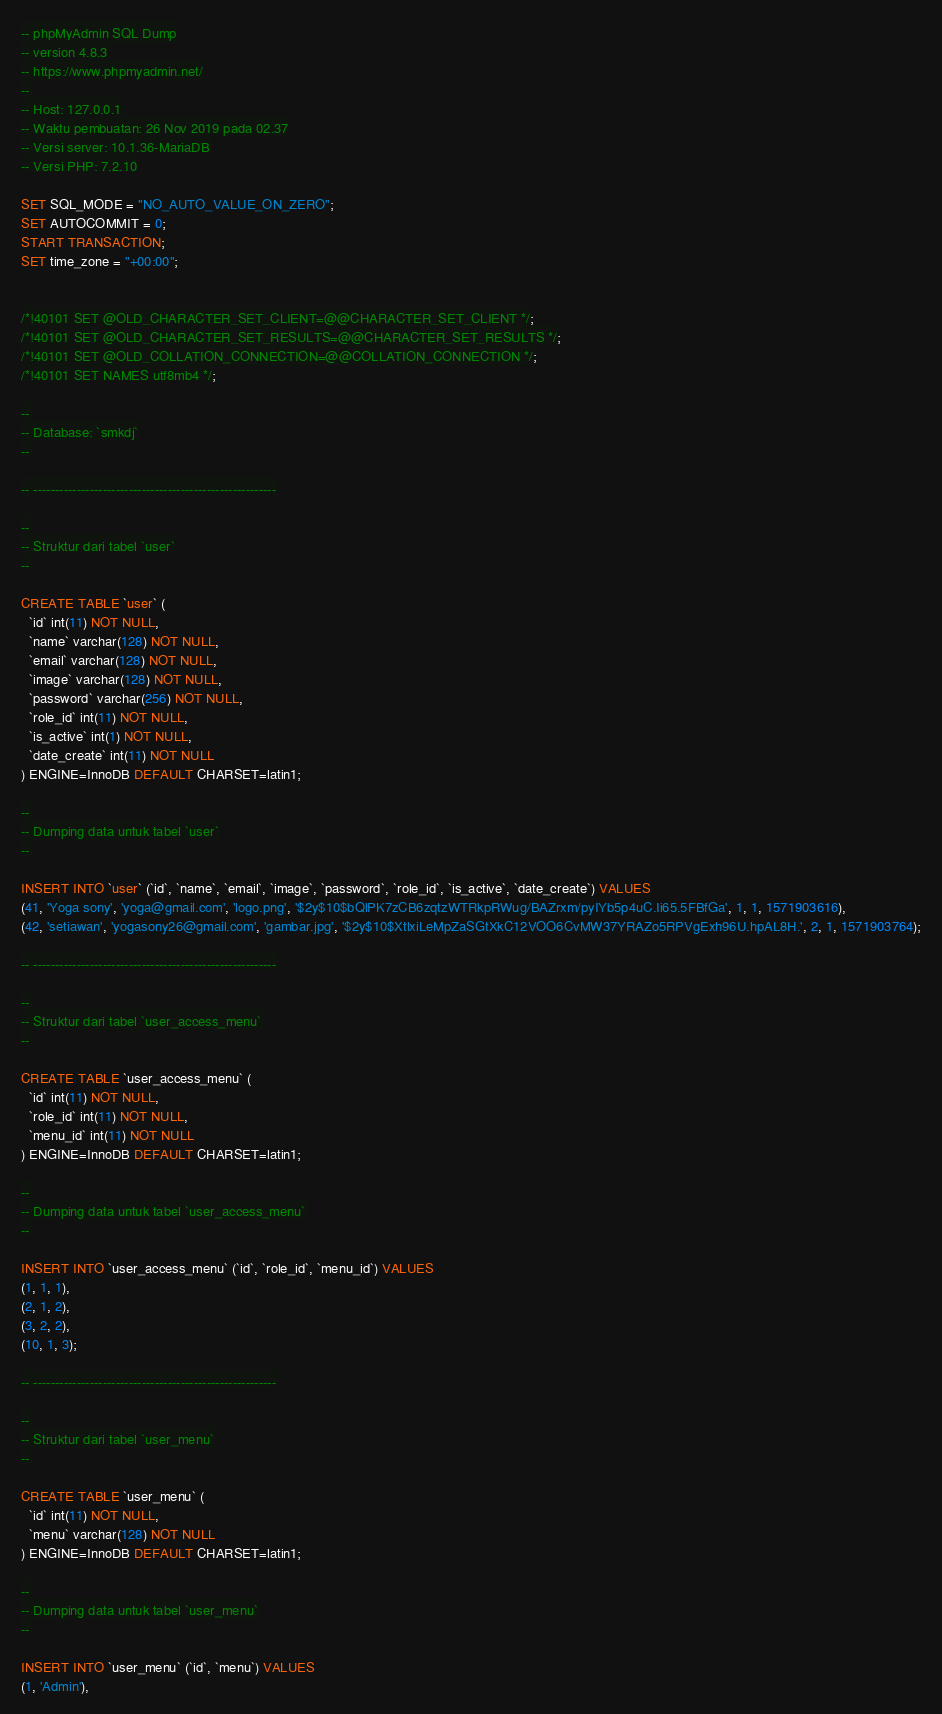<code> <loc_0><loc_0><loc_500><loc_500><_SQL_>-- phpMyAdmin SQL Dump
-- version 4.8.3
-- https://www.phpmyadmin.net/
--
-- Host: 127.0.0.1
-- Waktu pembuatan: 26 Nov 2019 pada 02.37
-- Versi server: 10.1.36-MariaDB
-- Versi PHP: 7.2.10

SET SQL_MODE = "NO_AUTO_VALUE_ON_ZERO";
SET AUTOCOMMIT = 0;
START TRANSACTION;
SET time_zone = "+00:00";


/*!40101 SET @OLD_CHARACTER_SET_CLIENT=@@CHARACTER_SET_CLIENT */;
/*!40101 SET @OLD_CHARACTER_SET_RESULTS=@@CHARACTER_SET_RESULTS */;
/*!40101 SET @OLD_COLLATION_CONNECTION=@@COLLATION_CONNECTION */;
/*!40101 SET NAMES utf8mb4 */;

--
-- Database: `smkdj`
--

-- --------------------------------------------------------

--
-- Struktur dari tabel `user`
--

CREATE TABLE `user` (
  `id` int(11) NOT NULL,
  `name` varchar(128) NOT NULL,
  `email` varchar(128) NOT NULL,
  `image` varchar(128) NOT NULL,
  `password` varchar(256) NOT NULL,
  `role_id` int(11) NOT NULL,
  `is_active` int(1) NOT NULL,
  `date_create` int(11) NOT NULL
) ENGINE=InnoDB DEFAULT CHARSET=latin1;

--
-- Dumping data untuk tabel `user`
--

INSERT INTO `user` (`id`, `name`, `email`, `image`, `password`, `role_id`, `is_active`, `date_create`) VALUES
(41, 'Yoga sony', 'yoga@gmail.com', 'logo.png', '$2y$10$bQlPK7zCB6zqtzWTRkpRWug/BAZrxm/pyIYb5p4uC.Ii65.5FBfGa', 1, 1, 1571903616),
(42, 'setiawan', 'yogasony26@gmail.com', 'gambar.jpg', '$2y$10$XtlxiLeMpZaSGtXkC12VOO6CvMW37YRAZo5RPVgExh96U.hpAL8H.', 2, 1, 1571903764);

-- --------------------------------------------------------

--
-- Struktur dari tabel `user_access_menu`
--

CREATE TABLE `user_access_menu` (
  `id` int(11) NOT NULL,
  `role_id` int(11) NOT NULL,
  `menu_id` int(11) NOT NULL
) ENGINE=InnoDB DEFAULT CHARSET=latin1;

--
-- Dumping data untuk tabel `user_access_menu`
--

INSERT INTO `user_access_menu` (`id`, `role_id`, `menu_id`) VALUES
(1, 1, 1),
(2, 1, 2),
(3, 2, 2),
(10, 1, 3);

-- --------------------------------------------------------

--
-- Struktur dari tabel `user_menu`
--

CREATE TABLE `user_menu` (
  `id` int(11) NOT NULL,
  `menu` varchar(128) NOT NULL
) ENGINE=InnoDB DEFAULT CHARSET=latin1;

--
-- Dumping data untuk tabel `user_menu`
--

INSERT INTO `user_menu` (`id`, `menu`) VALUES
(1, 'Admin'),</code> 